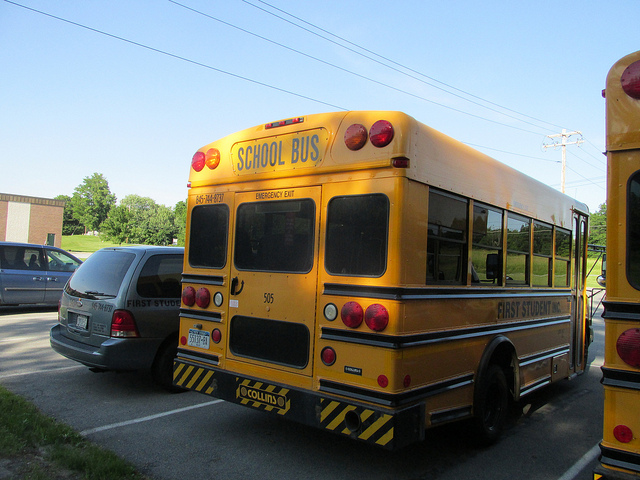<image>How many passengers can each vehicle hold? It is ambiguous how many passengers each vehicle can hold. How many passengers can each vehicle hold? It is unknown how many passengers each vehicle can hold. 